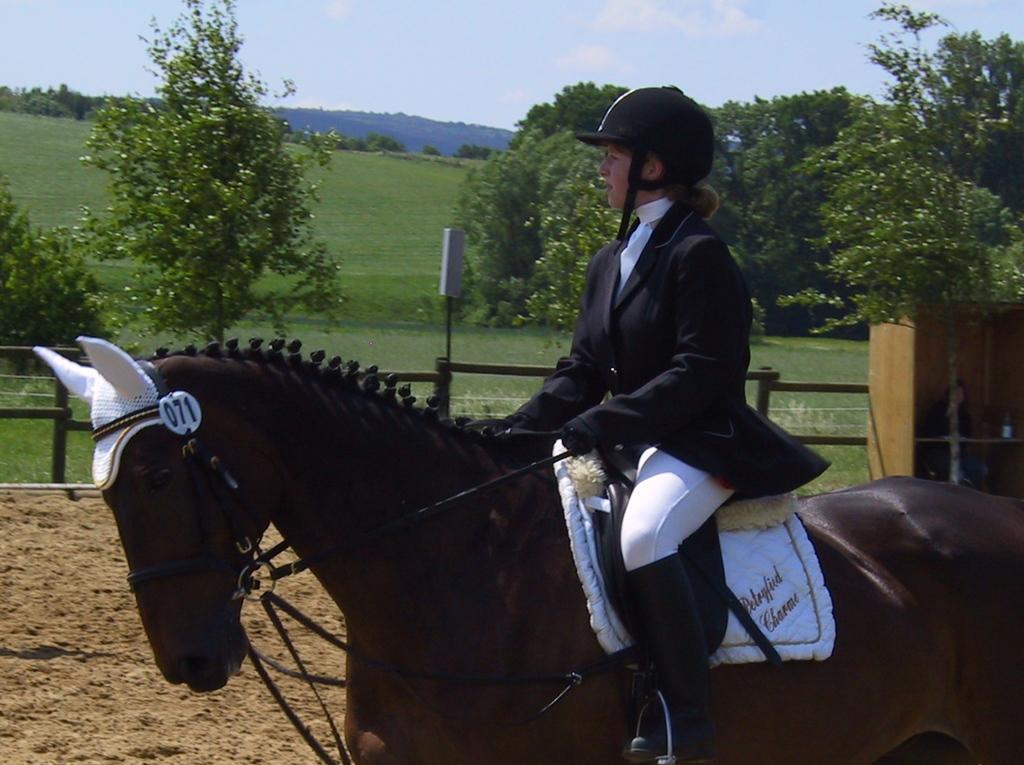Describe this image in one or two sentences. In the image we can see a person wearing clothes, gloves, shoes, helmet and the person is sitting on the horse. Here we can see sand, fence and trees. We can even see grass, hill and the sky. 